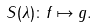Convert formula to latex. <formula><loc_0><loc_0><loc_500><loc_500>S ( \lambda ) \colon f \mapsto g .</formula> 